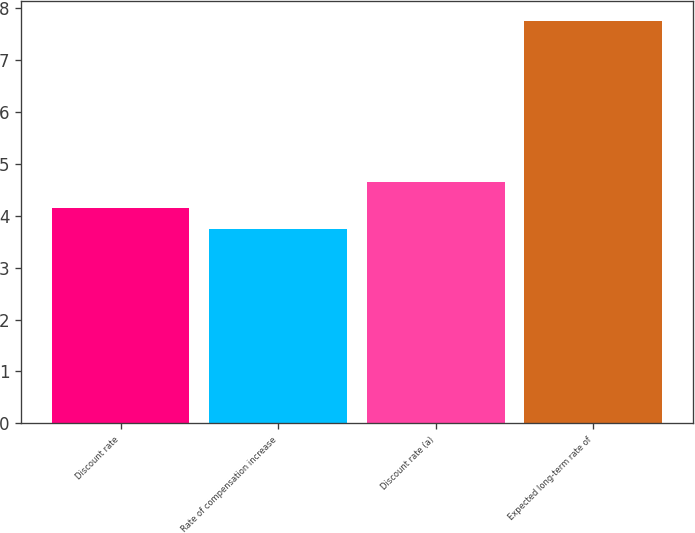Convert chart. <chart><loc_0><loc_0><loc_500><loc_500><bar_chart><fcel>Discount rate<fcel>Rate of compensation increase<fcel>Discount rate (a)<fcel>Expected long-term rate of<nl><fcel>4.15<fcel>3.75<fcel>4.65<fcel>7.75<nl></chart> 